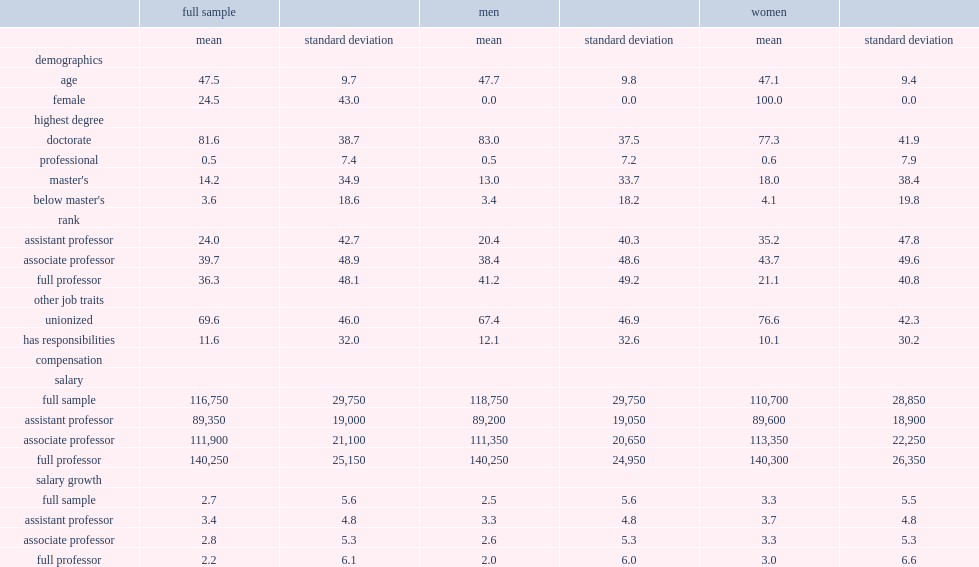What are the age and the percentage of women of all individuals? 47.5 24.5. What were the percentages of faculty members holding a doctorate and belonging to unionized institutions respectively? 81.6 69.6. Who are more likely to be unionized,women or men? Women. 